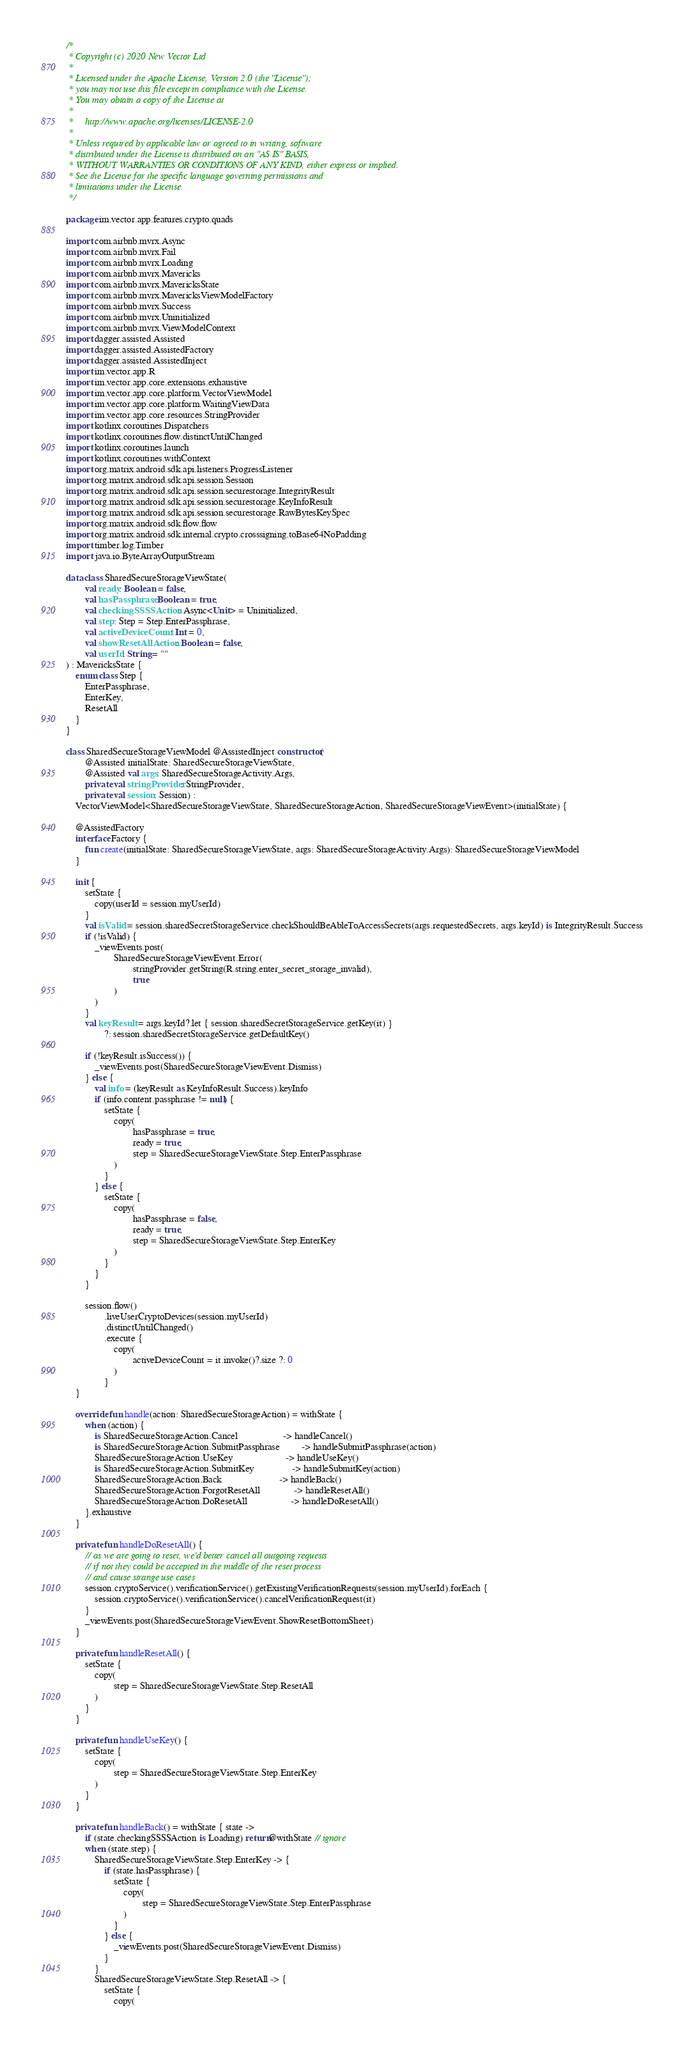<code> <loc_0><loc_0><loc_500><loc_500><_Kotlin_>/*
 * Copyright (c) 2020 New Vector Ltd
 *
 * Licensed under the Apache License, Version 2.0 (the "License");
 * you may not use this file except in compliance with the License.
 * You may obtain a copy of the License at
 *
 *     http://www.apache.org/licenses/LICENSE-2.0
 *
 * Unless required by applicable law or agreed to in writing, software
 * distributed under the License is distributed on an "AS IS" BASIS,
 * WITHOUT WARRANTIES OR CONDITIONS OF ANY KIND, either express or implied.
 * See the License for the specific language governing permissions and
 * limitations under the License.
 */

package im.vector.app.features.crypto.quads

import com.airbnb.mvrx.Async
import com.airbnb.mvrx.Fail
import com.airbnb.mvrx.Loading
import com.airbnb.mvrx.Mavericks
import com.airbnb.mvrx.MavericksState
import com.airbnb.mvrx.MavericksViewModelFactory
import com.airbnb.mvrx.Success
import com.airbnb.mvrx.Uninitialized
import com.airbnb.mvrx.ViewModelContext
import dagger.assisted.Assisted
import dagger.assisted.AssistedFactory
import dagger.assisted.AssistedInject
import im.vector.app.R
import im.vector.app.core.extensions.exhaustive
import im.vector.app.core.platform.VectorViewModel
import im.vector.app.core.platform.WaitingViewData
import im.vector.app.core.resources.StringProvider
import kotlinx.coroutines.Dispatchers
import kotlinx.coroutines.flow.distinctUntilChanged
import kotlinx.coroutines.launch
import kotlinx.coroutines.withContext
import org.matrix.android.sdk.api.listeners.ProgressListener
import org.matrix.android.sdk.api.session.Session
import org.matrix.android.sdk.api.session.securestorage.IntegrityResult
import org.matrix.android.sdk.api.session.securestorage.KeyInfoResult
import org.matrix.android.sdk.api.session.securestorage.RawBytesKeySpec
import org.matrix.android.sdk.flow.flow
import org.matrix.android.sdk.internal.crypto.crosssigning.toBase64NoPadding
import timber.log.Timber
import java.io.ByteArrayOutputStream

data class SharedSecureStorageViewState(
        val ready: Boolean = false,
        val hasPassphrase: Boolean = true,
        val checkingSSSSAction: Async<Unit> = Uninitialized,
        val step: Step = Step.EnterPassphrase,
        val activeDeviceCount: Int = 0,
        val showResetAllAction: Boolean = false,
        val userId: String = ""
) : MavericksState {
    enum class Step {
        EnterPassphrase,
        EnterKey,
        ResetAll
    }
}

class SharedSecureStorageViewModel @AssistedInject constructor(
        @Assisted initialState: SharedSecureStorageViewState,
        @Assisted val args: SharedSecureStorageActivity.Args,
        private val stringProvider: StringProvider,
        private val session: Session) :
    VectorViewModel<SharedSecureStorageViewState, SharedSecureStorageAction, SharedSecureStorageViewEvent>(initialState) {

    @AssistedFactory
    interface Factory {
        fun create(initialState: SharedSecureStorageViewState, args: SharedSecureStorageActivity.Args): SharedSecureStorageViewModel
    }

    init {
        setState {
            copy(userId = session.myUserId)
        }
        val isValid = session.sharedSecretStorageService.checkShouldBeAbleToAccessSecrets(args.requestedSecrets, args.keyId) is IntegrityResult.Success
        if (!isValid) {
            _viewEvents.post(
                    SharedSecureStorageViewEvent.Error(
                            stringProvider.getString(R.string.enter_secret_storage_invalid),
                            true
                    )
            )
        }
        val keyResult = args.keyId?.let { session.sharedSecretStorageService.getKey(it) }
                ?: session.sharedSecretStorageService.getDefaultKey()

        if (!keyResult.isSuccess()) {
            _viewEvents.post(SharedSecureStorageViewEvent.Dismiss)
        } else {
            val info = (keyResult as KeyInfoResult.Success).keyInfo
            if (info.content.passphrase != null) {
                setState {
                    copy(
                            hasPassphrase = true,
                            ready = true,
                            step = SharedSecureStorageViewState.Step.EnterPassphrase
                    )
                }
            } else {
                setState {
                    copy(
                            hasPassphrase = false,
                            ready = true,
                            step = SharedSecureStorageViewState.Step.EnterKey
                    )
                }
            }
        }

        session.flow()
                .liveUserCryptoDevices(session.myUserId)
                .distinctUntilChanged()
                .execute {
                    copy(
                            activeDeviceCount = it.invoke()?.size ?: 0
                    )
                }
    }

    override fun handle(action: SharedSecureStorageAction) = withState {
        when (action) {
            is SharedSecureStorageAction.Cancel                   -> handleCancel()
            is SharedSecureStorageAction.SubmitPassphrase         -> handleSubmitPassphrase(action)
            SharedSecureStorageAction.UseKey                      -> handleUseKey()
            is SharedSecureStorageAction.SubmitKey                -> handleSubmitKey(action)
            SharedSecureStorageAction.Back                        -> handleBack()
            SharedSecureStorageAction.ForgotResetAll              -> handleResetAll()
            SharedSecureStorageAction.DoResetAll                  -> handleDoResetAll()
        }.exhaustive
    }

    private fun handleDoResetAll() {
        // as we are going to reset, we'd better cancel all outgoing requests
        // if not they could be accepted in the middle of the reset process
        // and cause strange use cases
        session.cryptoService().verificationService().getExistingVerificationRequests(session.myUserId).forEach {
            session.cryptoService().verificationService().cancelVerificationRequest(it)
        }
        _viewEvents.post(SharedSecureStorageViewEvent.ShowResetBottomSheet)
    }

    private fun handleResetAll() {
        setState {
            copy(
                    step = SharedSecureStorageViewState.Step.ResetAll
            )
        }
    }

    private fun handleUseKey() {
        setState {
            copy(
                    step = SharedSecureStorageViewState.Step.EnterKey
            )
        }
    }

    private fun handleBack() = withState { state ->
        if (state.checkingSSSSAction is Loading) return@withState // ignore
        when (state.step) {
            SharedSecureStorageViewState.Step.EnterKey -> {
                if (state.hasPassphrase) {
                    setState {
                        copy(
                                step = SharedSecureStorageViewState.Step.EnterPassphrase
                        )
                    }
                } else {
                    _viewEvents.post(SharedSecureStorageViewEvent.Dismiss)
                }
            }
            SharedSecureStorageViewState.Step.ResetAll -> {
                setState {
                    copy(</code> 